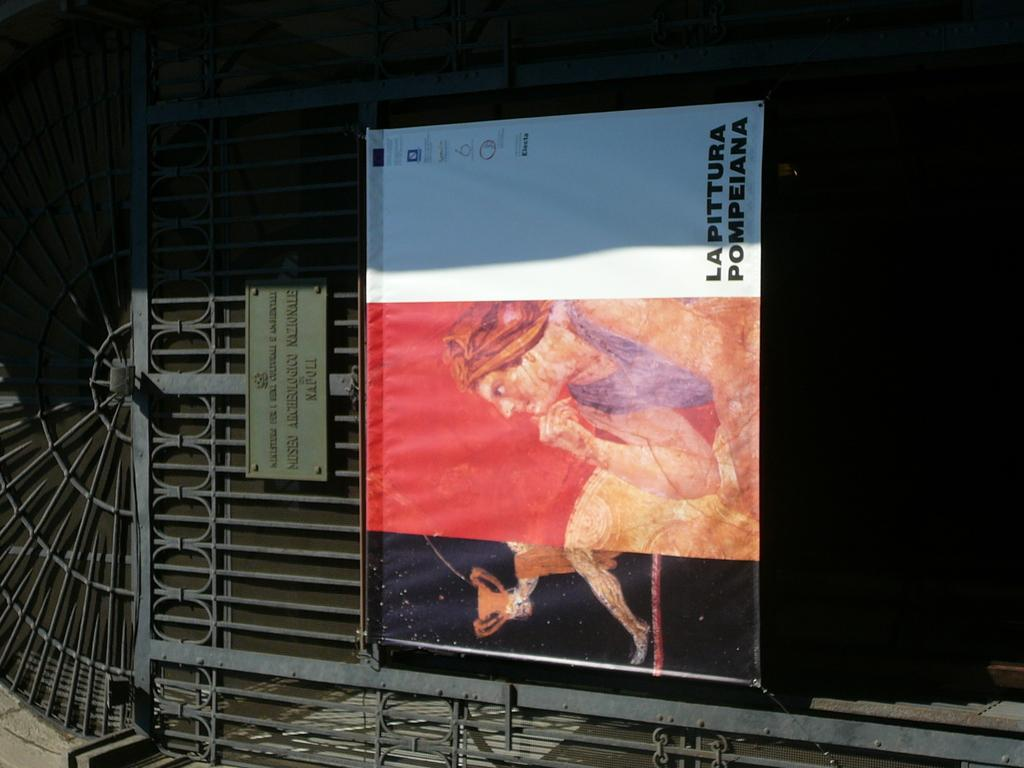<image>
Relay a brief, clear account of the picture shown. A banner advertising La Pittura Pompeiana hangs on a dark iron gate. 